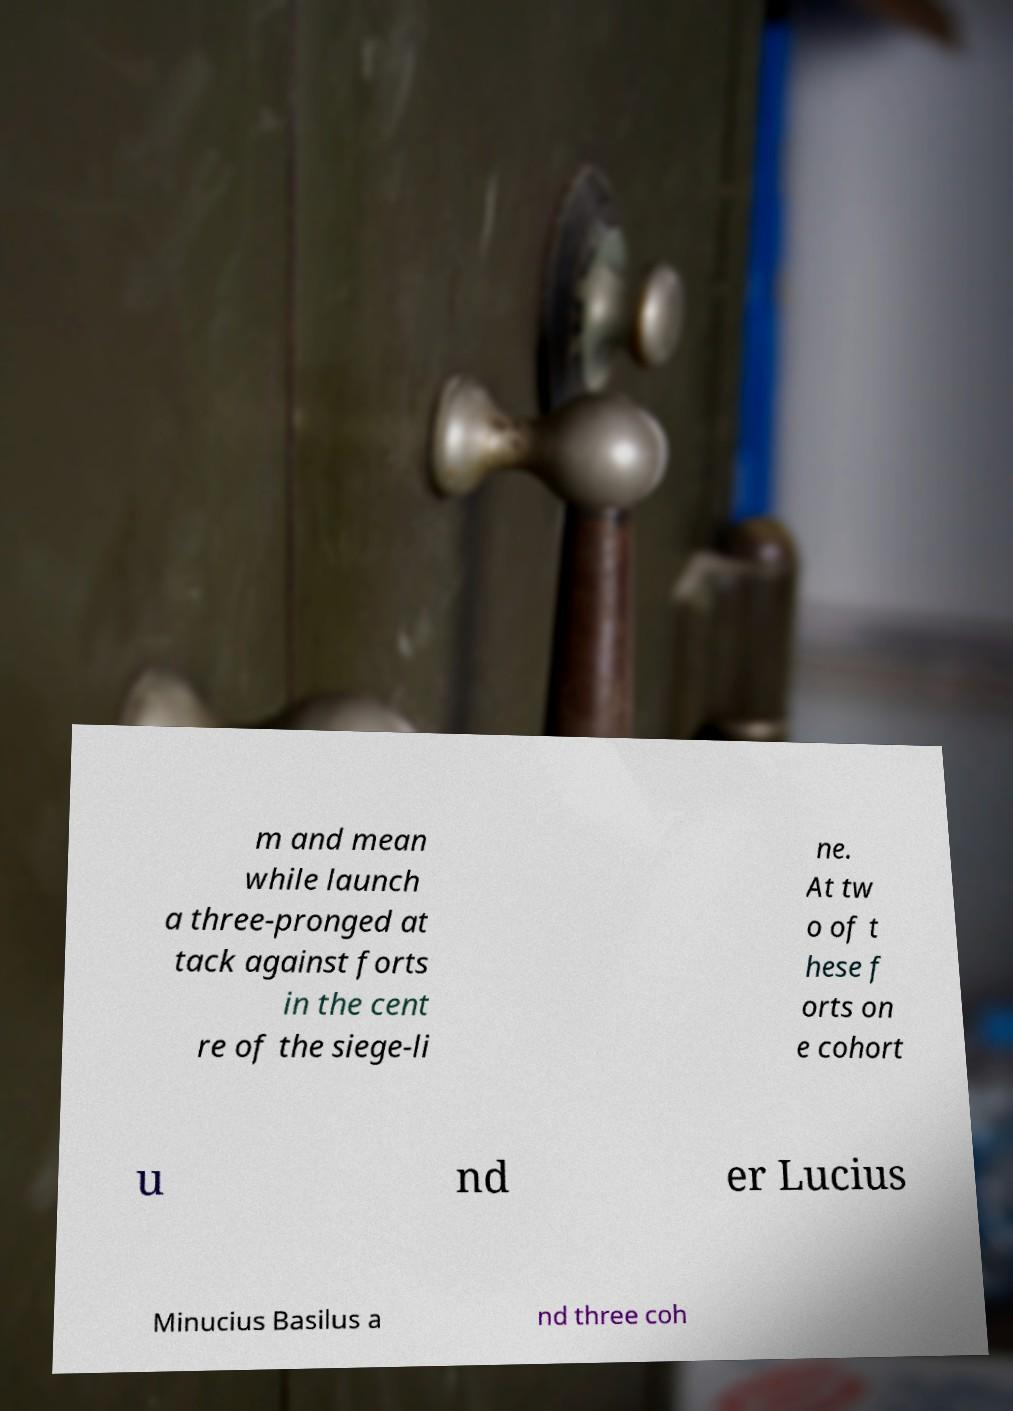Please read and relay the text visible in this image. What does it say? m and mean while launch a three-pronged at tack against forts in the cent re of the siege-li ne. At tw o of t hese f orts on e cohort u nd er Lucius Minucius Basilus a nd three coh 